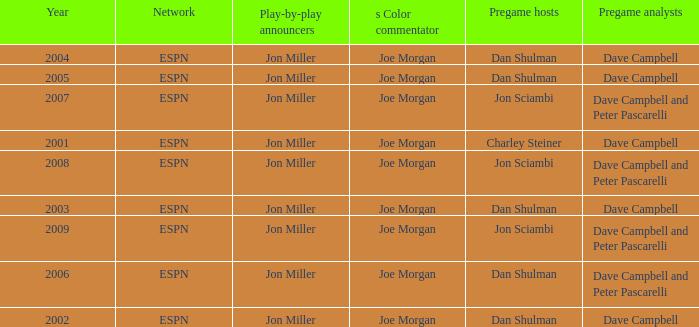Who is the pregame host when the pregame analysts is  Dave Campbell and the year is 2001? Charley Steiner. 